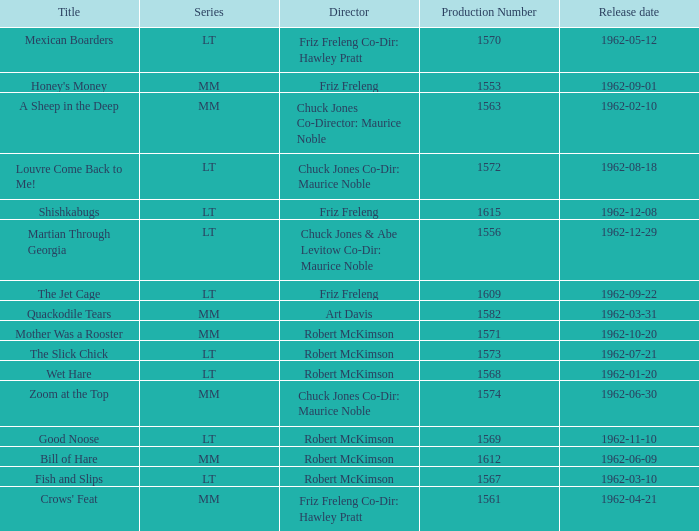What is Crows' Feat's production number? 1561.0. 